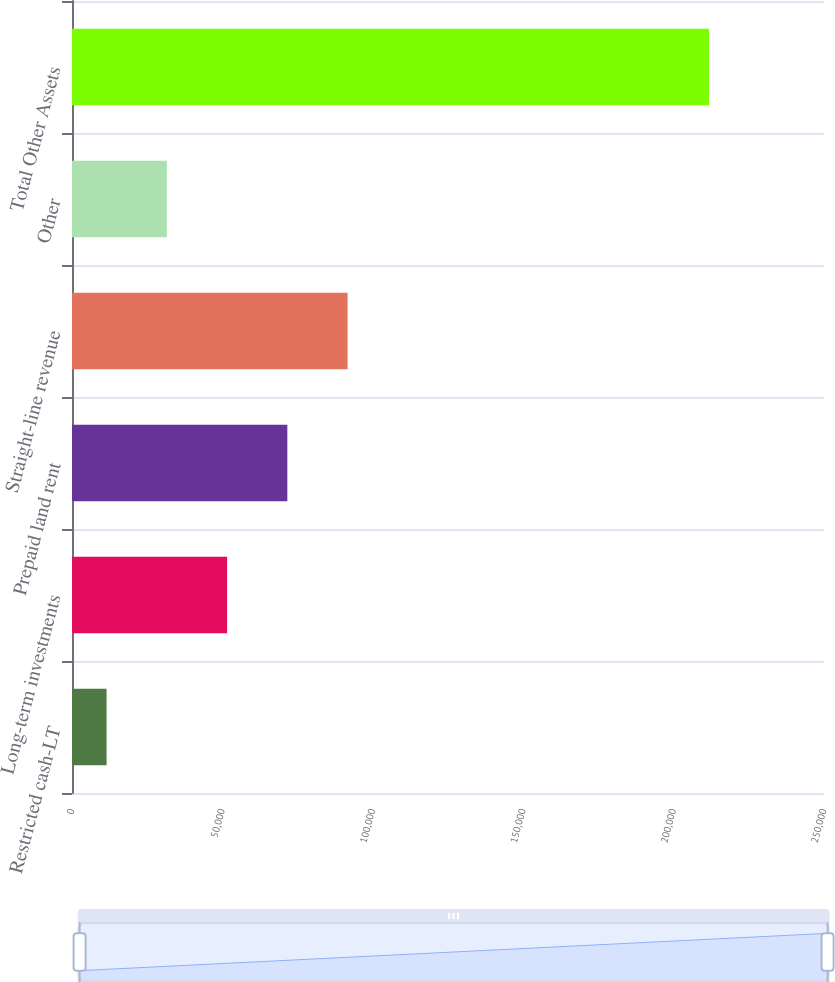Convert chart to OTSL. <chart><loc_0><loc_0><loc_500><loc_500><bar_chart><fcel>Restricted cash-LT<fcel>Long-term investments<fcel>Prepaid land rent<fcel>Straight-line revenue<fcel>Other<fcel>Total Other Assets<nl><fcel>11495<fcel>51556.4<fcel>71587.1<fcel>91617.8<fcel>31525.7<fcel>211802<nl></chart> 